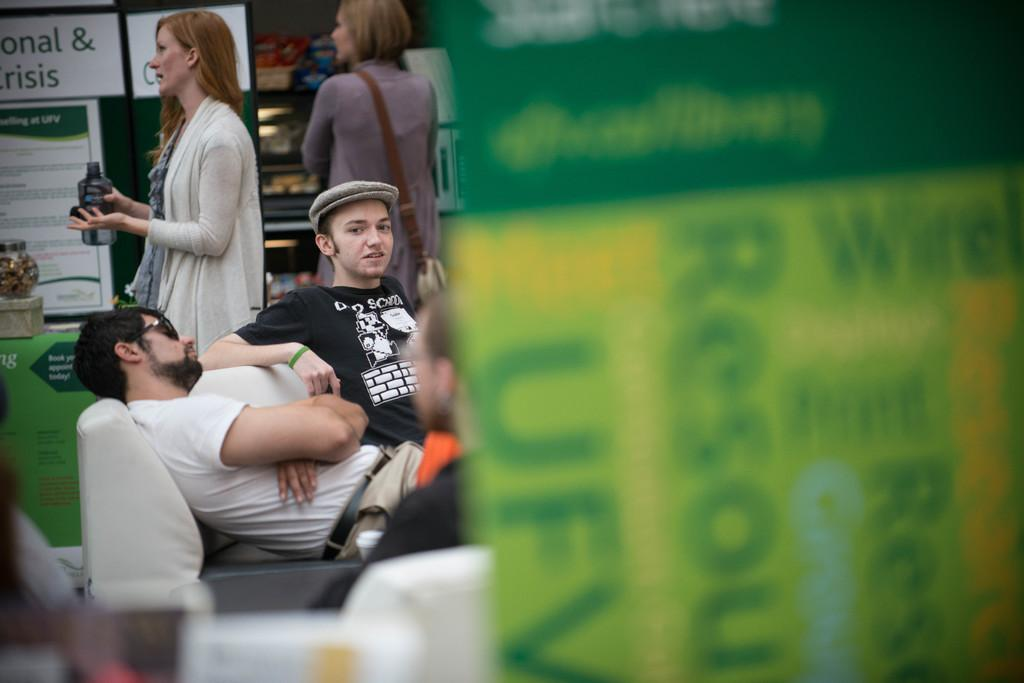What are the people in the image doing? There are people sitting on a bench in the image. Are there any other individuals present in the image? Yes, there are women standing beside the bench. What can be seen in the background of the image? There are shops visible in the background of the image. What sense is being stimulated by the sand in the image? There is no sand present in the image, so it cannot stimulate any senses. 